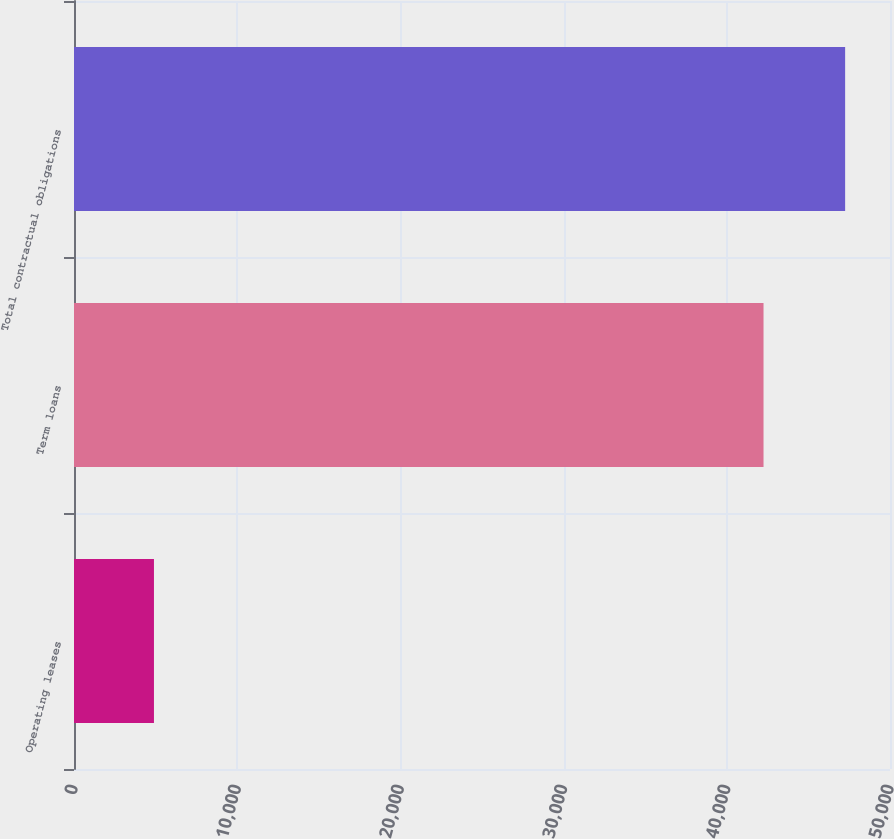<chart> <loc_0><loc_0><loc_500><loc_500><bar_chart><fcel>Operating leases<fcel>Term loans<fcel>Total contractual obligations<nl><fcel>4899<fcel>42250<fcel>47251<nl></chart> 